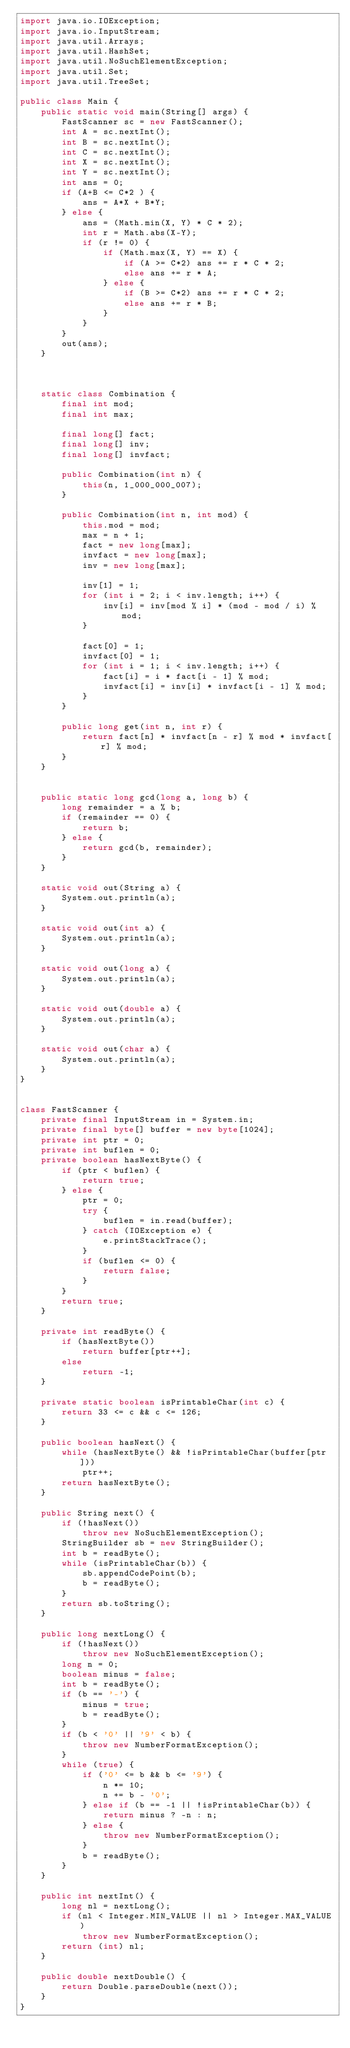Convert code to text. <code><loc_0><loc_0><loc_500><loc_500><_Java_>import java.io.IOException;
import java.io.InputStream;
import java.util.Arrays;
import java.util.HashSet;
import java.util.NoSuchElementException;
import java.util.Set;
import java.util.TreeSet;

public class Main {
	public static void main(String[] args) {
		FastScanner sc = new FastScanner();
		int A = sc.nextInt();
		int B = sc.nextInt();
		int C = sc.nextInt();
		int X = sc.nextInt();
		int Y = sc.nextInt();
		int ans = 0;
		if (A+B <= C*2 ) {
			ans = A*X + B*Y;
		} else {
			ans = (Math.min(X, Y) * C * 2);
			int r = Math.abs(X-Y);
			if (r != 0) {
				if (Math.max(X, Y) == X) {
					if (A >= C*2) ans += r * C * 2;
					else ans += r * A;
				} else {
					if (B >= C*2) ans += r * C * 2;
					else ans += r * B;
				}
			}
		}
		out(ans);
	}



	static class Combination {
		final int mod;
		final int max;

		final long[] fact;
		final long[] inv;
		final long[] invfact;

		public Combination(int n) {
			this(n, 1_000_000_007);
		}

		public Combination(int n, int mod) {
			this.mod = mod;
			max = n + 1;
			fact = new long[max];
			invfact = new long[max];
			inv = new long[max];

			inv[1] = 1;
			for (int i = 2; i < inv.length; i++) {
				inv[i] = inv[mod % i] * (mod - mod / i) % mod;
			}

			fact[0] = 1;
			invfact[0] = 1;
			for (int i = 1; i < inv.length; i++) {
				fact[i] = i * fact[i - 1] % mod;
				invfact[i] = inv[i] * invfact[i - 1] % mod;
			}
		}

		public long get(int n, int r) {
			return fact[n] * invfact[n - r] % mod * invfact[r] % mod;
		}
	}


	public static long gcd(long a, long b) {
		long remainder = a % b;
		if (remainder == 0) {
			return b;
		} else {
			return gcd(b, remainder);
		}
	}

	static void out(String a) {
		System.out.println(a);
	}

	static void out(int a) {
		System.out.println(a);
	}

	static void out(long a) {
		System.out.println(a);
	}

	static void out(double a) {
		System.out.println(a);
	}

	static void out(char a) {
		System.out.println(a);
	}
}


class FastScanner {
    private final InputStream in = System.in;
    private final byte[] buffer = new byte[1024];
    private int ptr = 0;
    private int buflen = 0;
    private boolean hasNextByte() {
        if (ptr < buflen) {
            return true;
        } else {
            ptr = 0;
            try {
                buflen = in.read(buffer);
            } catch (IOException e) {
                e.printStackTrace();
            }
            if (buflen <= 0) {
                return false;
            }
        }
        return true;
    }

    private int readByte() {
        if (hasNextByte())
            return buffer[ptr++];
        else
            return -1;
    }

    private static boolean isPrintableChar(int c) {
        return 33 <= c && c <= 126;
    }

    public boolean hasNext() {
        while (hasNextByte() && !isPrintableChar(buffer[ptr]))
            ptr++;
        return hasNextByte();
    }

    public String next() {
        if (!hasNext())
            throw new NoSuchElementException();
        StringBuilder sb = new StringBuilder();
        int b = readByte();
        while (isPrintableChar(b)) {
            sb.appendCodePoint(b);
            b = readByte();
        }
        return sb.toString();
    }

    public long nextLong() {
        if (!hasNext())
            throw new NoSuchElementException();
        long n = 0;
        boolean minus = false;
        int b = readByte();
        if (b == '-') {
            minus = true;
            b = readByte();
        }
        if (b < '0' || '9' < b) {
            throw new NumberFormatException();
        }
        while (true) {
            if ('0' <= b && b <= '9') {
                n *= 10;
                n += b - '0';
            } else if (b == -1 || !isPrintableChar(b)) {
                return minus ? -n : n;
            } else {
                throw new NumberFormatException();
            }
            b = readByte();
        }
    }

    public int nextInt() {
        long nl = nextLong();
        if (nl < Integer.MIN_VALUE || nl > Integer.MAX_VALUE)
            throw new NumberFormatException();
        return (int) nl;
    }

    public double nextDouble() {
        return Double.parseDouble(next());
    }
}
</code> 